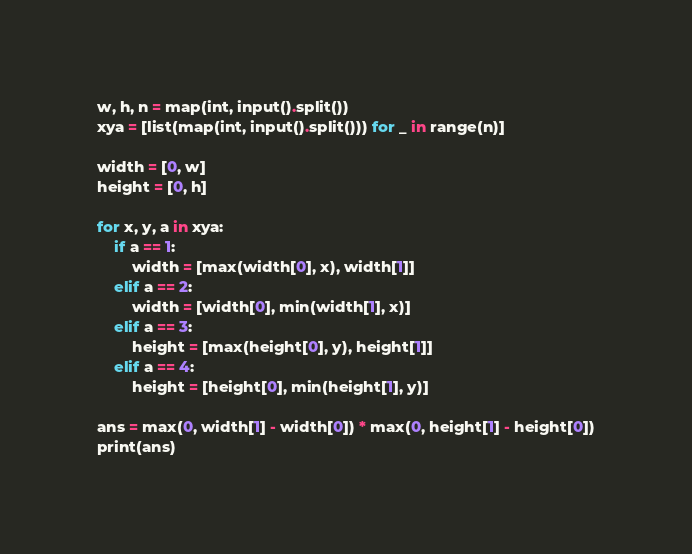<code> <loc_0><loc_0><loc_500><loc_500><_Python_>w, h, n = map(int, input().split())
xya = [list(map(int, input().split())) for _ in range(n)]

width = [0, w]
height = [0, h]

for x, y, a in xya:
    if a == 1:
        width = [max(width[0], x), width[1]]
    elif a == 2:
        width = [width[0], min(width[1], x)]
    elif a == 3:
        height = [max(height[0], y), height[1]]
    elif a == 4:
        height = [height[0], min(height[1], y)]

ans = max(0, width[1] - width[0]) * max(0, height[1] - height[0])
print(ans)
</code> 